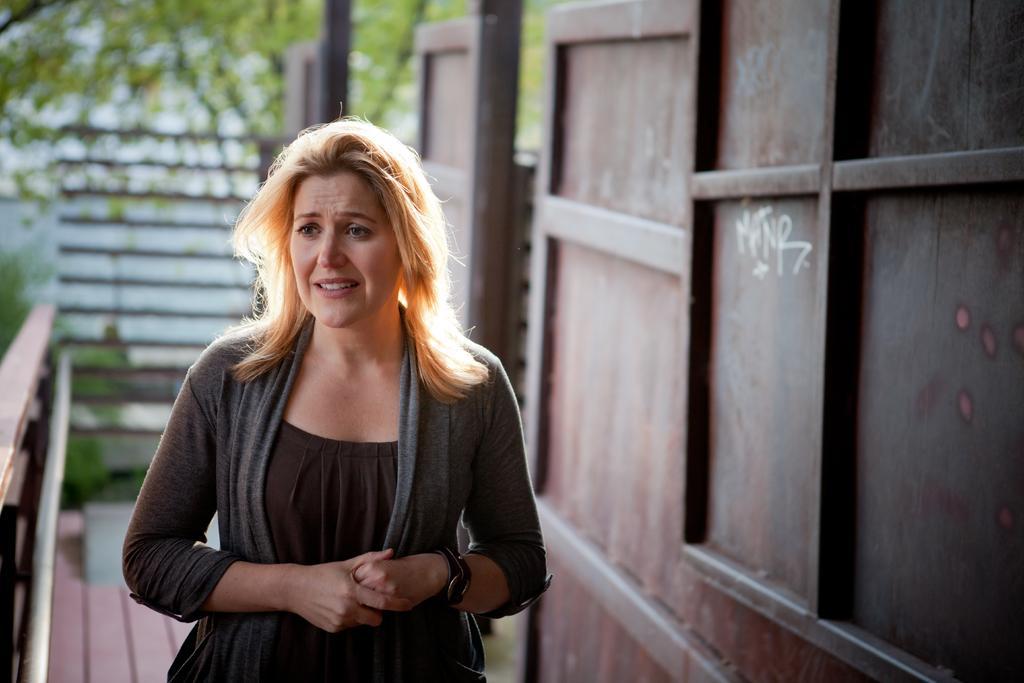Could you give a brief overview of what you see in this image? In the center of the image there is a woman wearing a grey color jacket. At the right side of the image there is a wall. At the left side of the image there is a railing. At the background of the image there is a tree. 